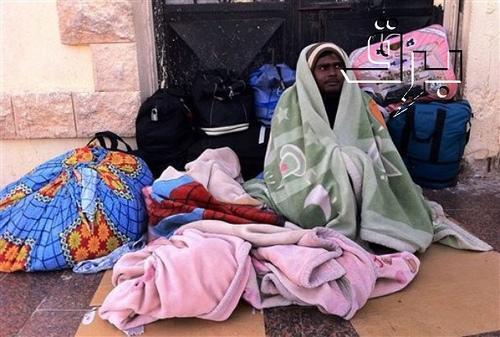How many men are in the picture?
Give a very brief answer. 1. 